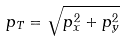<formula> <loc_0><loc_0><loc_500><loc_500>p _ { T } = \sqrt { p _ { x } ^ { 2 } + p _ { y } ^ { 2 } }</formula> 